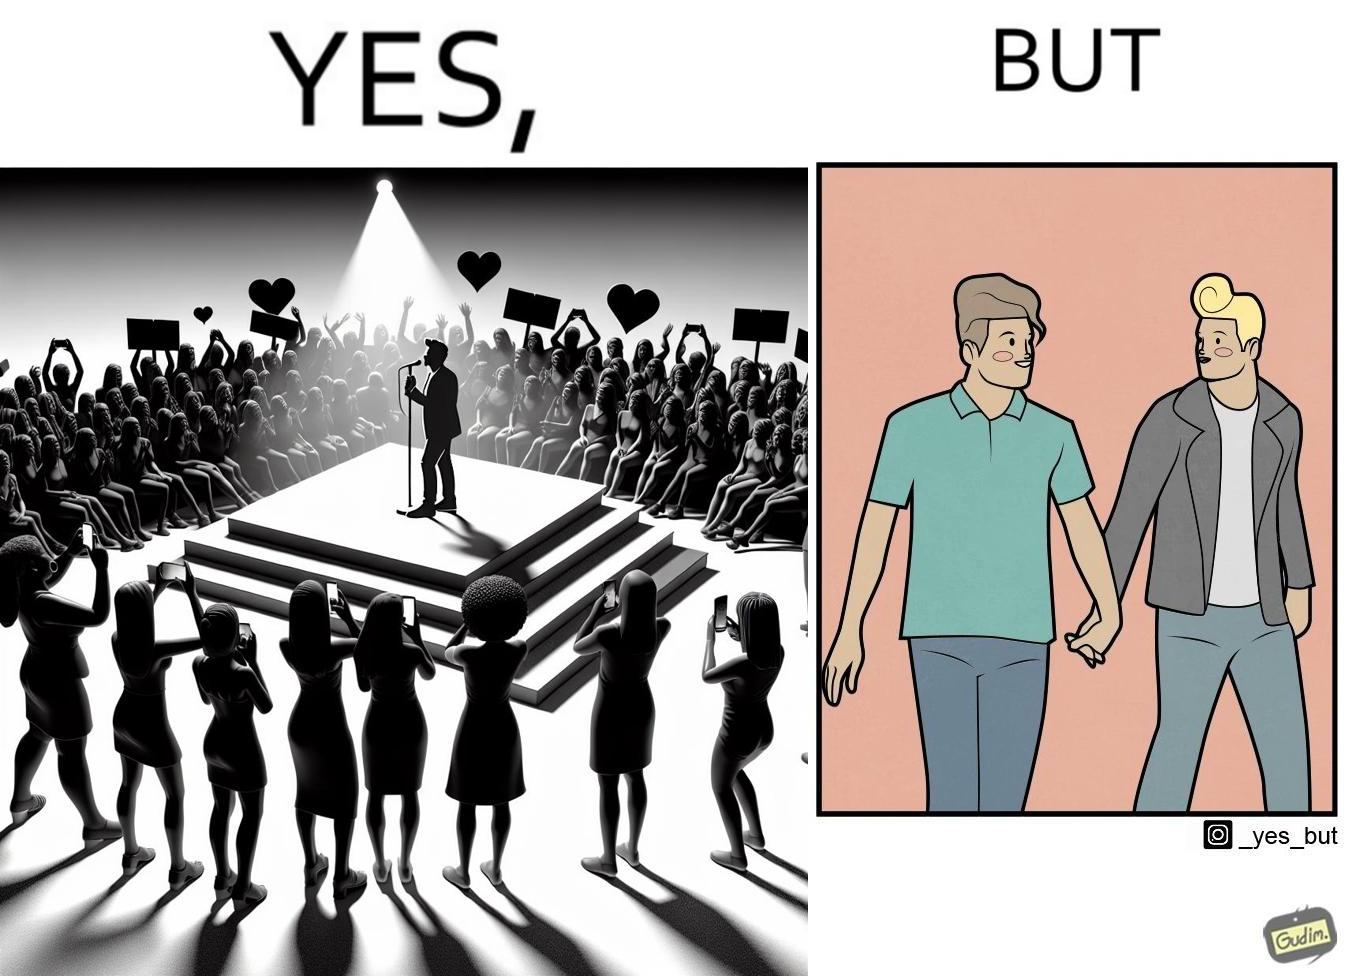Does this image contain satire or humor? Yes, this image is satirical. 